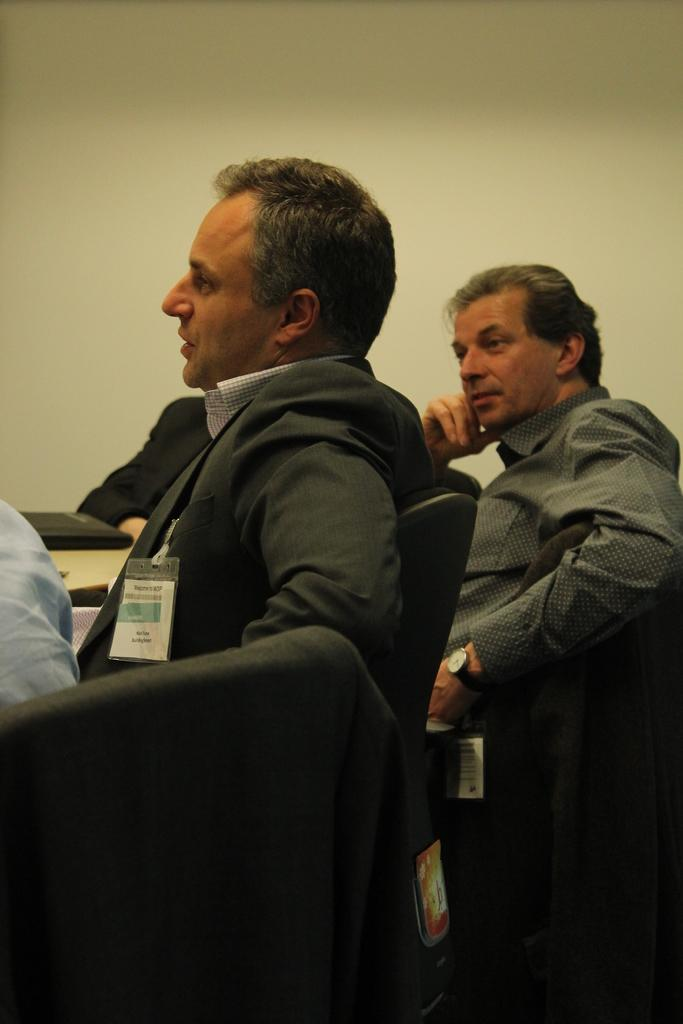How many people are in the image? There are few persons in the image. What is the man wearing in the image? The man is wearing a black suit. Can you describe any additional details about the man? The man is wearing a tag. What color are the chairs in the image? The chairs in the image are black. What can be seen in the background of the image? There is a wall in the background of the image. Is the turkey sleeping on the chairs in the image? There is no turkey present in the image, so it cannot be sleeping on the chairs. 